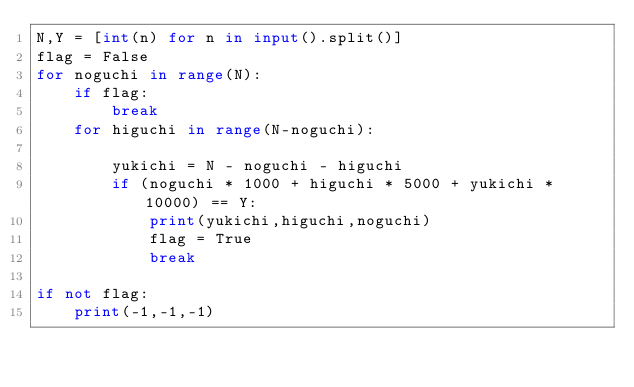Convert code to text. <code><loc_0><loc_0><loc_500><loc_500><_Python_>N,Y = [int(n) for n in input().split()]
flag = False
for noguchi in range(N):
    if flag:
        break
    for higuchi in range(N-noguchi):
        
        yukichi = N - noguchi - higuchi
        if (noguchi * 1000 + higuchi * 5000 + yukichi * 10000) == Y:
            print(yukichi,higuchi,noguchi)
            flag = True
            break
        
if not flag:
    print(-1,-1,-1)
</code> 